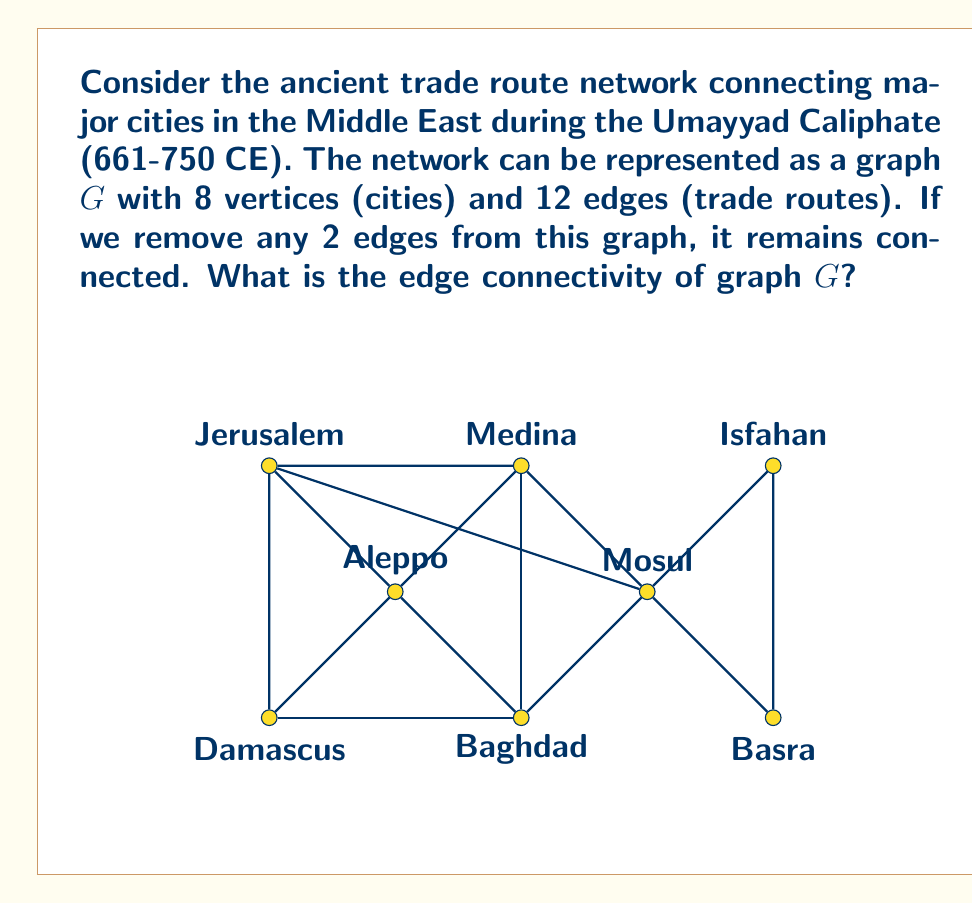Teach me how to tackle this problem. To solve this problem, let's follow these steps:

1) First, recall the definition of edge connectivity. The edge connectivity of a graph G, denoted by $\lambda(G)$, is the minimum number of edges that need to be removed to disconnect the graph.

2) We're given that removing any 2 edges keeps the graph connected. This means that $\lambda(G) > 2$.

3) To find $\lambda(G)$, we need to find the smallest number of edges that, when removed, disconnects the graph.

4) Let's consider removing 3 edges:
   - If we remove the 3 edges connecting Damascus (vertex 0) to the rest of the graph, it becomes isolated.
   - Similarly, we can isolate Basra (vertex 4) by removing its 3 connecting edges.

5) This means that $\lambda(G) \leq 3$.

6) Combining the results from steps 2 and 5, we can conclude that $\lambda(G) = 3$.

7) We can verify this by checking that no set of 2 edges, when removed, can disconnect the graph, but there exists at least one set of 3 edges (as shown in step 4) that disconnects the graph.

This edge connectivity value of 3 indicates that the ancient trade route network was relatively robust, requiring the disruption of at least 3 routes to isolate a city from the network.
Answer: $\lambda(G) = 3$ 